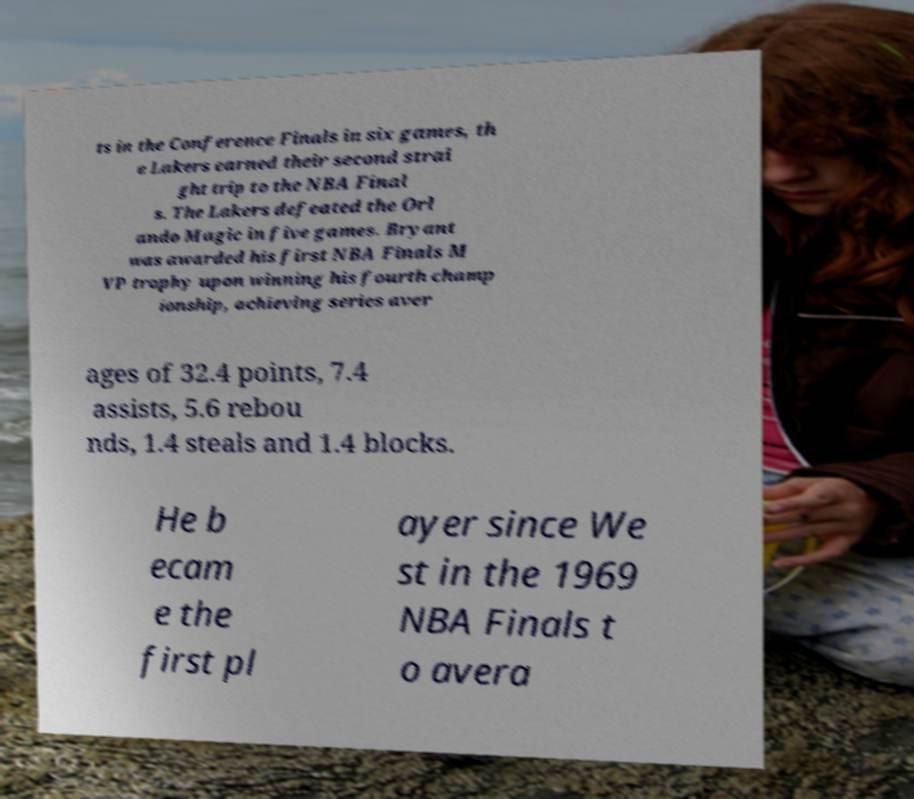Could you extract and type out the text from this image? ts in the Conference Finals in six games, th e Lakers earned their second strai ght trip to the NBA Final s. The Lakers defeated the Orl ando Magic in five games. Bryant was awarded his first NBA Finals M VP trophy upon winning his fourth champ ionship, achieving series aver ages of 32.4 points, 7.4 assists, 5.6 rebou nds, 1.4 steals and 1.4 blocks. He b ecam e the first pl ayer since We st in the 1969 NBA Finals t o avera 